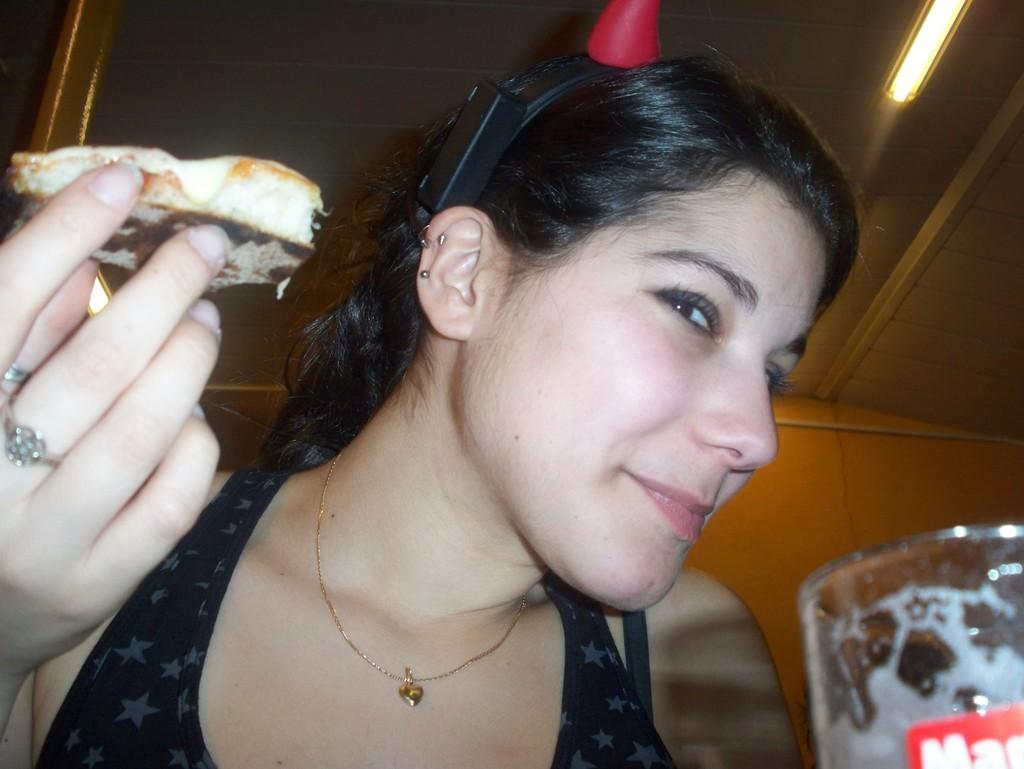Who is present in the image? There is a woman in the image. What is the woman holding in her hand? The woman is holding food in her hand. What can be seen on the table or surface in the image? There is a glass in the image. What is visible in the background of the image? There is a wall and a light in the background of the image. How does the woman use the brake in the image? There is no brake present in the image; it is a woman holding food and standing near a glass and a wall with a light in the background. 